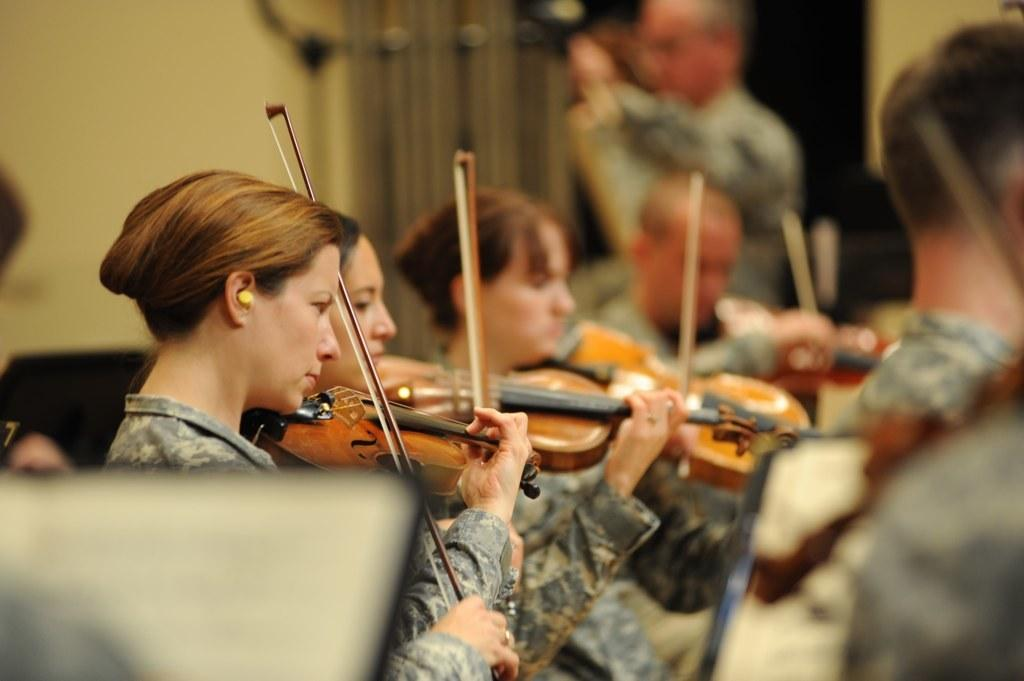What is happening in the image involving a group of people? There is a group of people in the image, and three women are holding musical instruments. What are the women doing with the musical instruments? The women are playing the instruments. What can be observed about the attire of the people in the group? All the people in the group are wearing the same uniform. What type of engine can be seen powering the musical instruments in the image? There is no engine present in the image, and the musical instruments are being played by the women, not powered by an engine. 